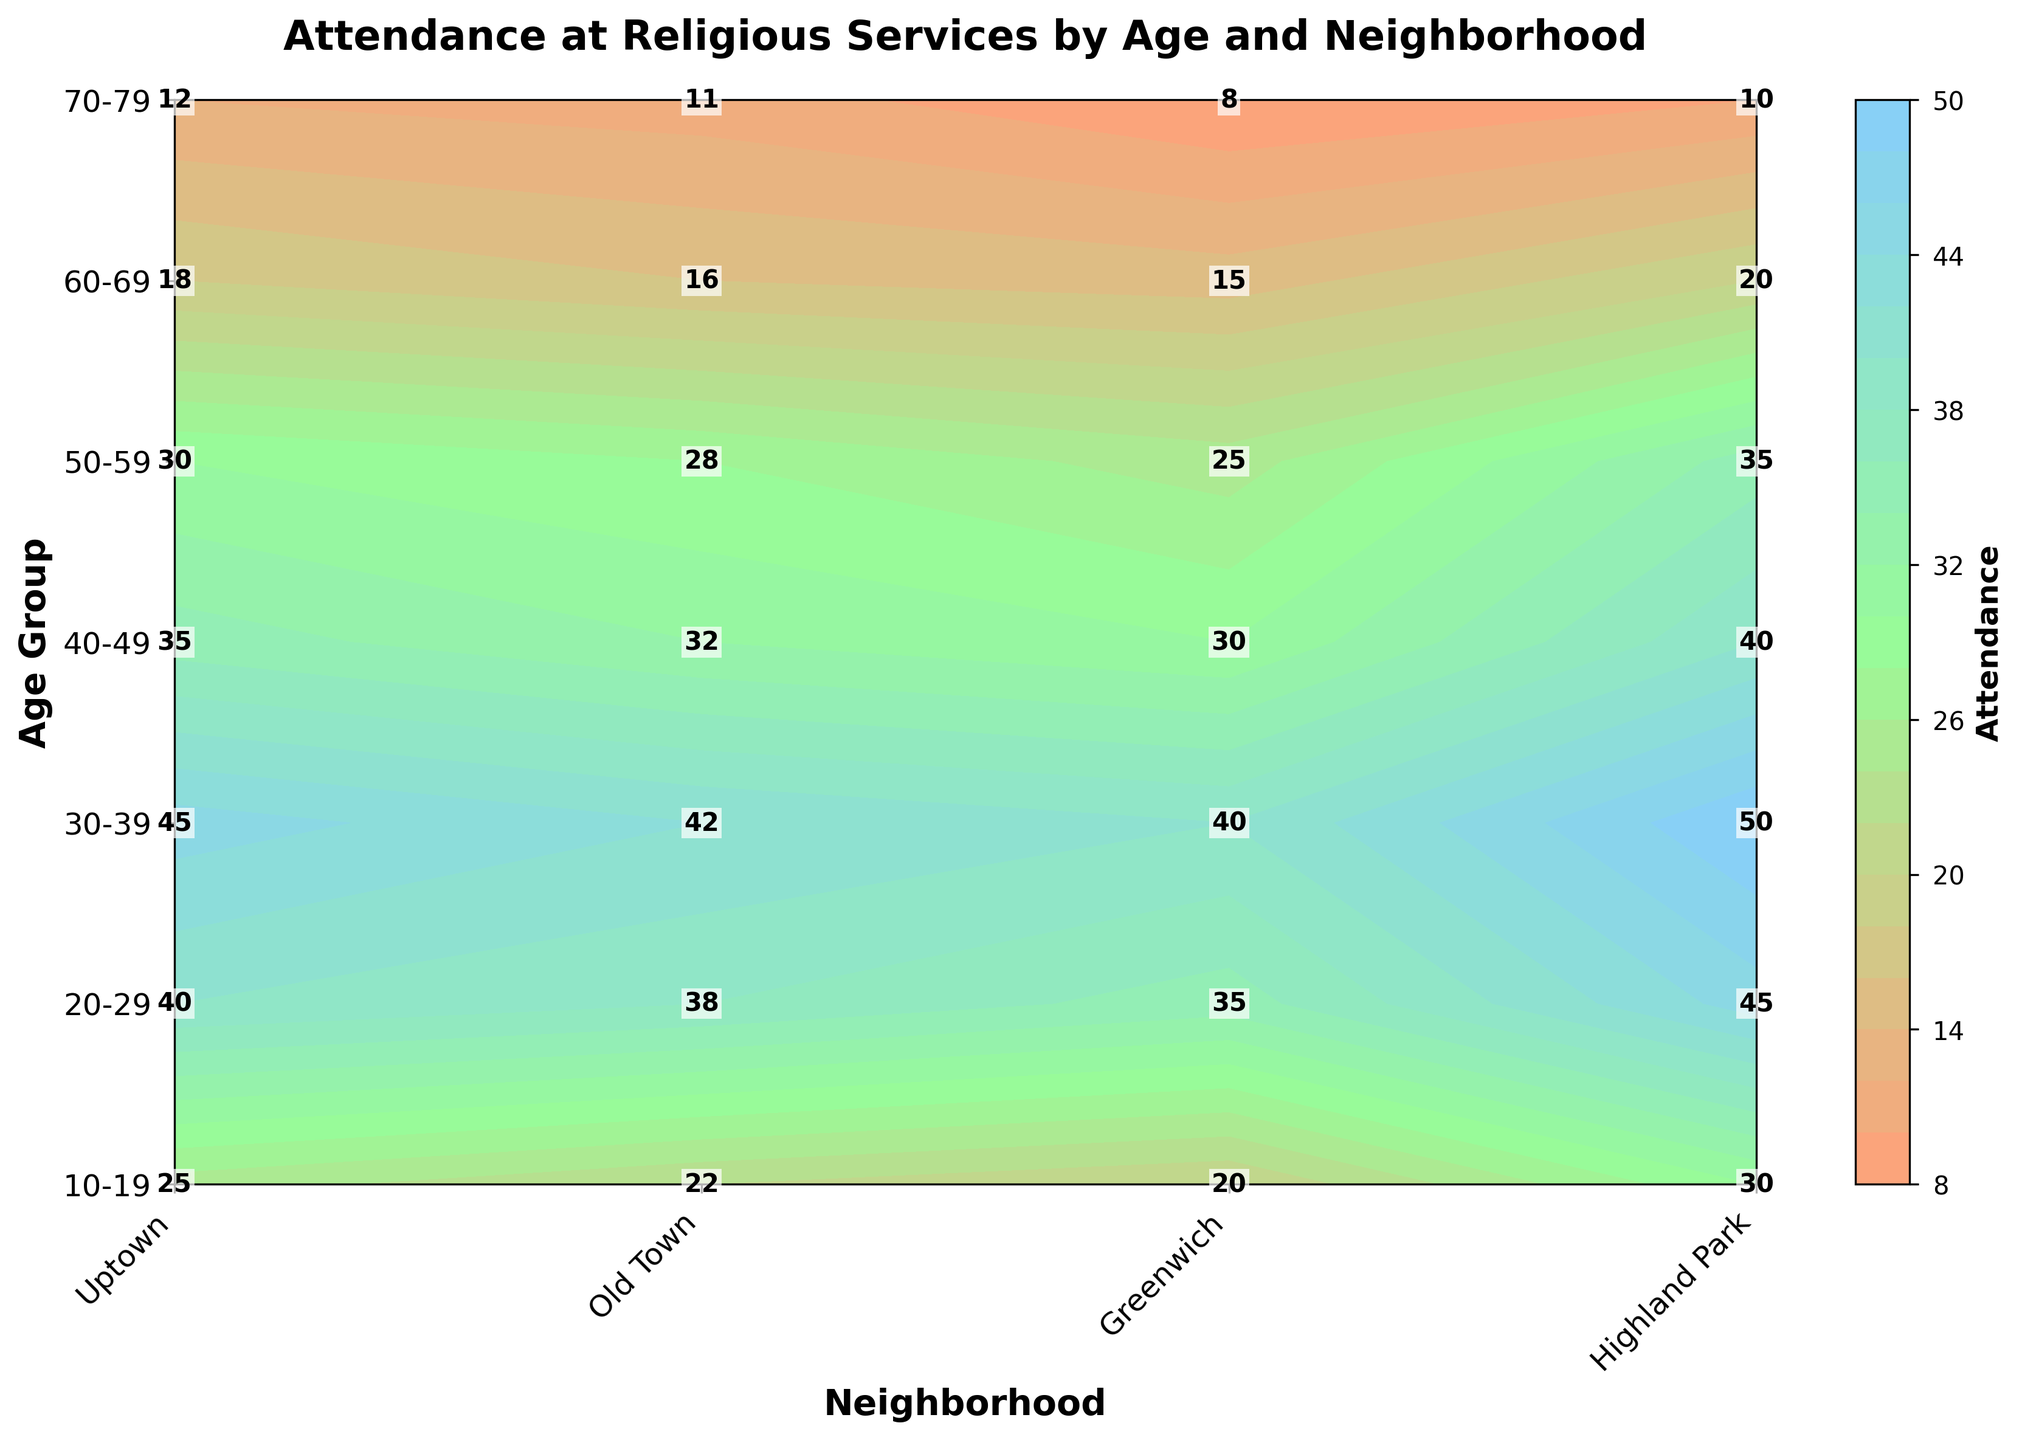How many age groups are represented in the plot? The figure shows various age groups on the vertical axis. By counting the unique ticks or labels on this axis, we see the age groups: '10-19', '20-29', '30-39', '40-49', '50-59', '60-69', '70-79'.
Answer: 7 Which neighborhood shows the highest attendance for the age group 30-39? Observing the contour plot and reading the corresponding cell for the age group 30-39, we compare the numbers for each neighborhood. 'Uptown' has the highest attendance with a value of 50.
Answer: Uptown What is the difference in attendance between the age groups 20-29 and 40-49 for 'Old Town'? Refer to the 'Old Town' column in the contour plot, find the attendance for age groups 20-29 and 40-49, which are 35 and 30 respectively. The difference is 35 - 30.
Answer: 5 What is the average attendance for 'Highland Park' across all age groups? Retrieve the attendance values for 'Highland Park' from each age group: 22, 38, 42, 32, 28, 16, 11. Sum these values and divide by the number of age groups, which is 7. (22 + 38 + 42 + 32 + 28 + 16 + 11) / 7 ≈ 27.
Answer: 27 Which age group has the lowest attendance in 'Uptown'? Looking at the 'Uptown' column, the number in the age group 70-79 shows the lowest attendance of 10.
Answer: 70-79 How does attendance in 'Greenwich' for the age group 50-59 compare to that in 'Uptown' for the same age group? Comparing the values from the contour plot for the age group 50-59 in 'Greenwich' (30) and 'Uptown' (35), we see that attendance in 'Greenwich' is lower than in 'Uptown'.
Answer: Lower What is the total attendance for the age group 60-69 across all neighborhoods? Summing the attendance values for age group 60-69 from all neighborhoods: 20 (Uptown) + 15 (Old Town) + 18 (Greenwich) + 16 (Highland Park) = 69.
Answer: 69 Which neighborhood shows the smallest variation in attendance across the age groups? Calculating the range (max - min) of attendance values for each neighborhood; 'Highland Park' has a range of (42 - 11 = 31), which is smaller compared to other neighborhoods. Therefore, 'Highland Park' shows the smallest variation.
Answer: Highland Park 